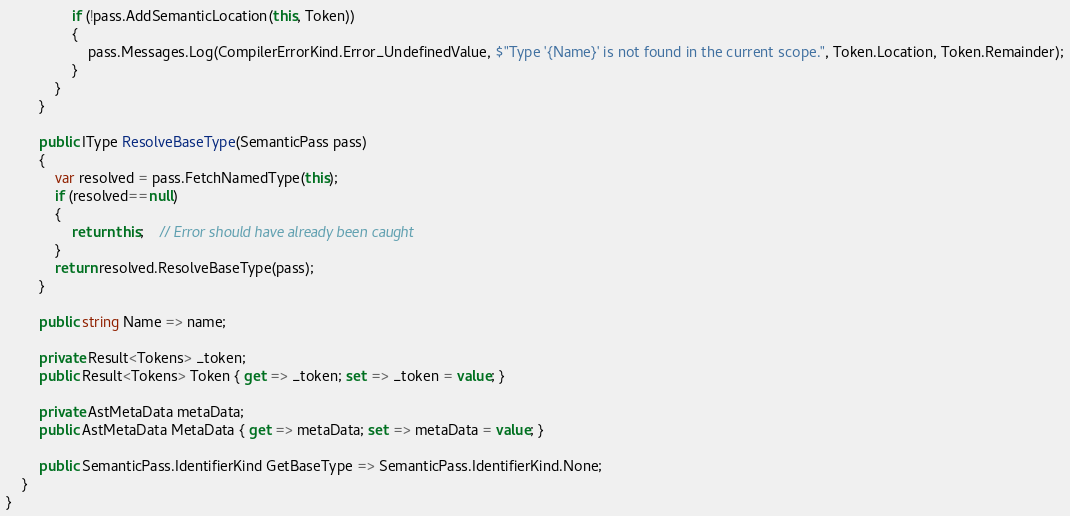<code> <loc_0><loc_0><loc_500><loc_500><_C#_>                if (!pass.AddSemanticLocation(this, Token))
                {
                    pass.Messages.Log(CompilerErrorKind.Error_UndefinedValue, $"Type '{Name}' is not found in the current scope.", Token.Location, Token.Remainder);
                }
            }
        }

        public IType ResolveBaseType(SemanticPass pass)
        {
            var resolved = pass.FetchNamedType(this);
            if (resolved==null)
            {
                return this;    // Error should have already been caught
            }
            return resolved.ResolveBaseType(pass);
        }

        public string Name => name;

        private Result<Tokens> _token;
        public Result<Tokens> Token { get => _token; set => _token = value; }

        private AstMetaData metaData;
        public AstMetaData MetaData { get => metaData; set => metaData = value; }

        public SemanticPass.IdentifierKind GetBaseType => SemanticPass.IdentifierKind.None;
    }
}

</code> 